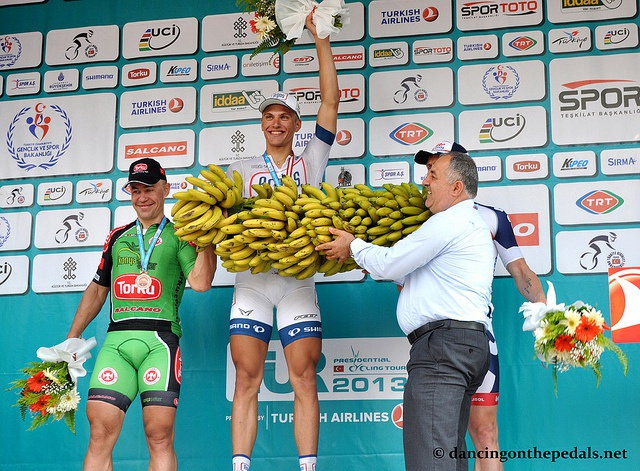Describe the objects in this image and their specific colors. I can see people in gray, white, and black tones, people in gray, black, brown, green, and lightgreen tones, people in gray, salmon, lightgray, darkgray, and tan tones, banana in gray, olive, and black tones, and people in gray, brown, lavender, navy, and salmon tones in this image. 